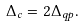<formula> <loc_0><loc_0><loc_500><loc_500>\Delta _ { c } = 2 \Delta _ { q p } .</formula> 